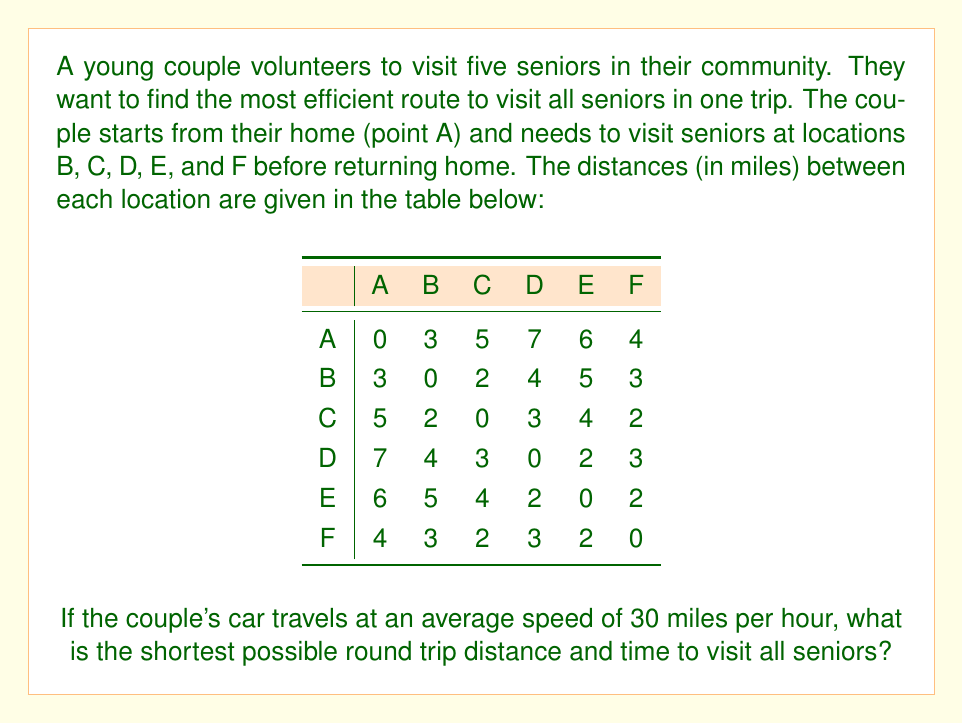Show me your answer to this math problem. To solve this problem, we need to find the shortest Hamiltonian cycle, which is a path that visits each location exactly once and returns to the starting point. This is known as the Traveling Salesman Problem.

For a small number of locations like this, we can use the brute force method to calculate all possible routes and find the shortest one.

The possible routes are:
1. A-B-C-D-E-F-A
2. A-B-C-D-F-E-A
3. A-B-C-E-D-F-A
4. A-B-C-E-F-D-A
5. A-B-C-F-D-E-A
6. A-B-C-F-E-D-A
... (and so on for all 120 permutations)

Let's calculate the distance for the first route as an example:
A to B: 3 miles
B to C: 2 miles
C to D: 3 miles
D to E: 2 miles
E to F: 2 miles
F to A: 4 miles

Total distance = 3 + 2 + 3 + 2 + 2 + 4 = 16 miles

After calculating all possible routes, we find that the shortest route is:
A-B-C-F-E-D-A

The distance for this route is:
A to B: 3 miles
B to C: 2 miles
C to F: 2 miles
F to E: 2 miles
E to D: 2 miles
D to A: 7 miles

Total distance = 3 + 2 + 2 + 2 + 2 + 7 = 18 miles

To calculate the time, we use the formula:
$$\text{Time} = \frac{\text{Distance}}{\text{Speed}}$$

$$\text{Time} = \frac{18 \text{ miles}}{30 \text{ miles/hour}} = 0.6 \text{ hours} = 36 \text{ minutes}$$
Answer: The shortest possible round trip distance is 18 miles, and the time taken is 36 minutes. 